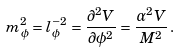Convert formula to latex. <formula><loc_0><loc_0><loc_500><loc_500>m _ { \phi } ^ { 2 } = l _ { \phi } ^ { - 2 } = \frac { \partial ^ { 2 } V } { \partial \phi ^ { 2 } } = \frac { \alpha ^ { 2 } V } { M ^ { 2 } } \, .</formula> 